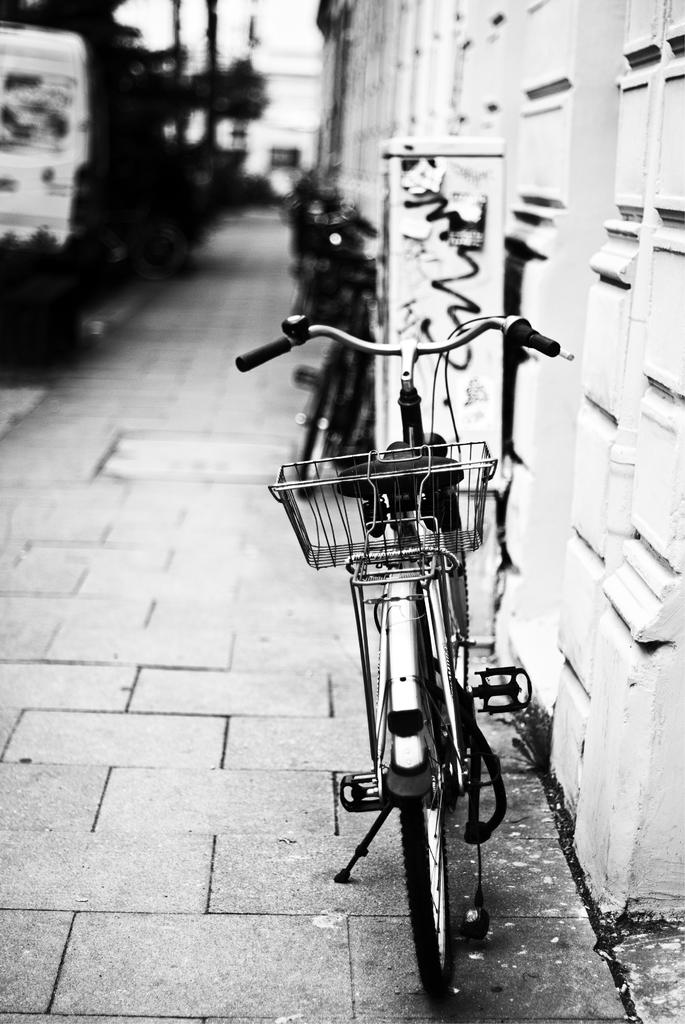What type of vehicles are present in the image? There are bicycles in the image. What can be seen in the distance behind the bicycles? There are buildings and trees in the background of the image. What type of chalk is being used to draw on the ground in the image? There is no chalk or drawing on the ground present in the image. 